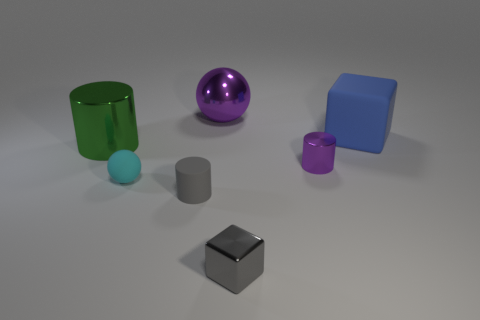Are there any gray objects in front of the tiny gray rubber thing?
Your response must be concise. Yes. What number of small purple objects have the same shape as the large green metallic thing?
Offer a terse response. 1. Is the material of the big purple object the same as the small thing that is behind the small cyan matte ball?
Give a very brief answer. Yes. What number of green metallic cylinders are there?
Give a very brief answer. 1. What size is the rubber object to the right of the big purple object?
Provide a succinct answer. Large. What number of cyan rubber things have the same size as the cyan sphere?
Your answer should be compact. 0. What is the material of the large object that is on the left side of the large blue block and to the right of the big green metal object?
Provide a short and direct response. Metal. There is a green cylinder that is the same size as the metal ball; what material is it?
Keep it short and to the point. Metal. There is a purple metal thing that is in front of the shiny object that is on the left side of the small matte thing that is behind the matte cylinder; what size is it?
Your answer should be very brief. Small. There is a block that is made of the same material as the tiny purple cylinder; what size is it?
Make the answer very short. Small. 